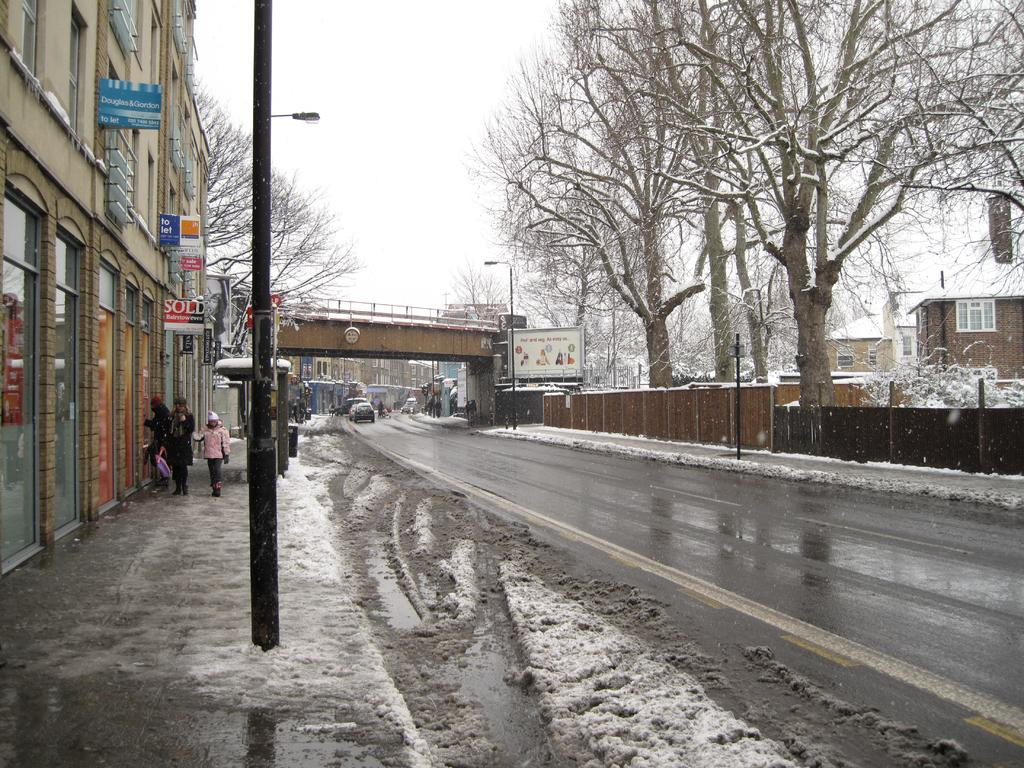What is the main feature of the image? There is a road in the image. What can be seen to the left of the road? There is snow to the left of the image. What structures are visible along the road? There are buildings and poles in the image. What is in the middle of the image? There is a bridge in the middle of the image. What type of vegetation is present to the right of the road? There are trees to the right of the image. What type of barrier is present to the right of the trees? There is fencing to the right of the image. What type of dress is the snow wearing in the image? There is no dress present in the image, as the snow is not a person or object that can wear clothing. 